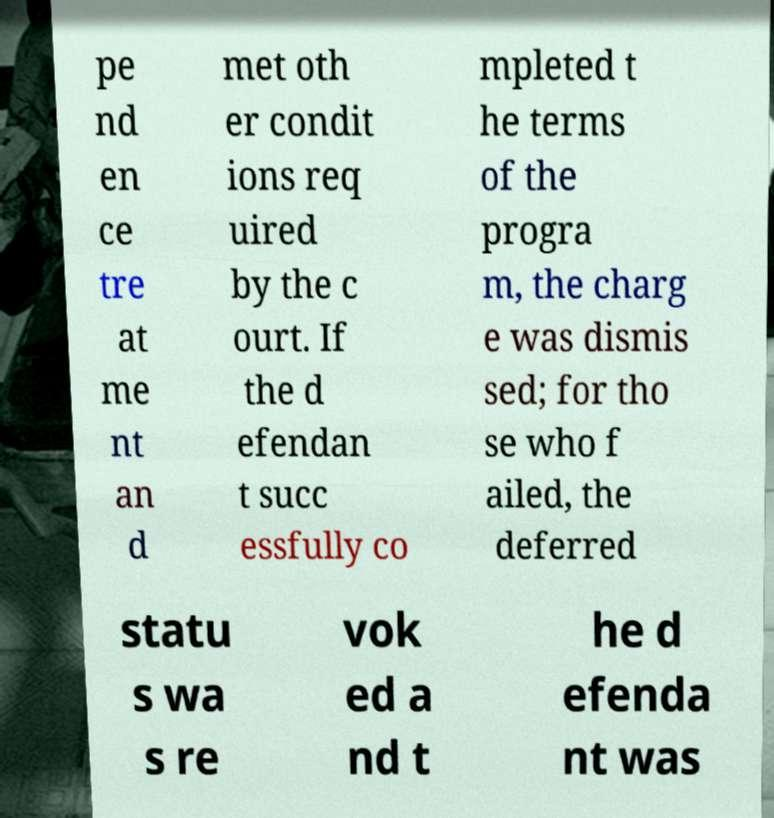Can you read and provide the text displayed in the image?This photo seems to have some interesting text. Can you extract and type it out for me? pe nd en ce tre at me nt an d met oth er condit ions req uired by the c ourt. If the d efendan t succ essfully co mpleted t he terms of the progra m, the charg e was dismis sed; for tho se who f ailed, the deferred statu s wa s re vok ed a nd t he d efenda nt was 